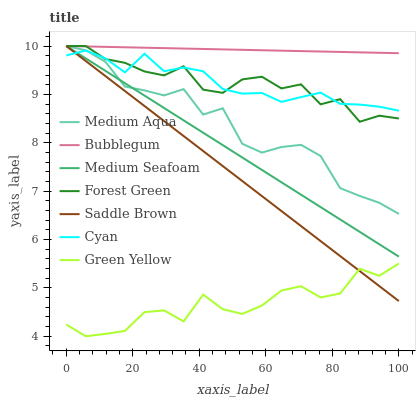Does Green Yellow have the minimum area under the curve?
Answer yes or no. Yes. Does Bubblegum have the maximum area under the curve?
Answer yes or no. Yes. Does Saddle Brown have the minimum area under the curve?
Answer yes or no. No. Does Saddle Brown have the maximum area under the curve?
Answer yes or no. No. Is Saddle Brown the smoothest?
Answer yes or no. Yes. Is Green Yellow the roughest?
Answer yes or no. Yes. Is Forest Green the smoothest?
Answer yes or no. No. Is Forest Green the roughest?
Answer yes or no. No. Does Saddle Brown have the lowest value?
Answer yes or no. No. Does Medium Seafoam have the highest value?
Answer yes or no. Yes. Does Cyan have the highest value?
Answer yes or no. No. Is Cyan less than Bubblegum?
Answer yes or no. Yes. Is Forest Green greater than Green Yellow?
Answer yes or no. Yes. Does Medium Seafoam intersect Saddle Brown?
Answer yes or no. Yes. Is Medium Seafoam less than Saddle Brown?
Answer yes or no. No. Is Medium Seafoam greater than Saddle Brown?
Answer yes or no. No. Does Cyan intersect Bubblegum?
Answer yes or no. No. 